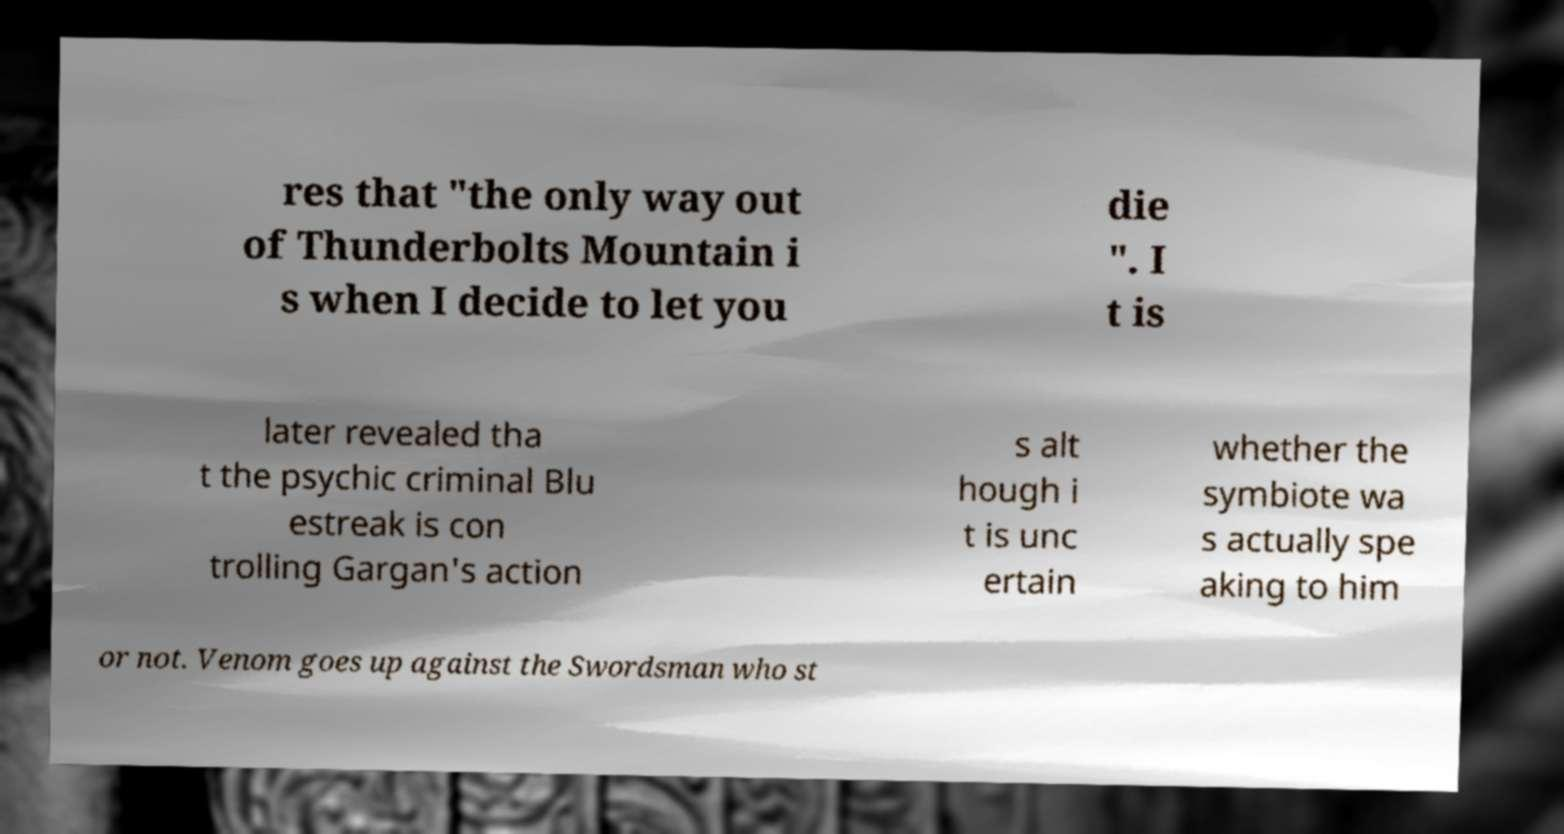Please identify and transcribe the text found in this image. res that "the only way out of Thunderbolts Mountain i s when I decide to let you die ". I t is later revealed tha t the psychic criminal Blu estreak is con trolling Gargan's action s alt hough i t is unc ertain whether the symbiote wa s actually spe aking to him or not. Venom goes up against the Swordsman who st 